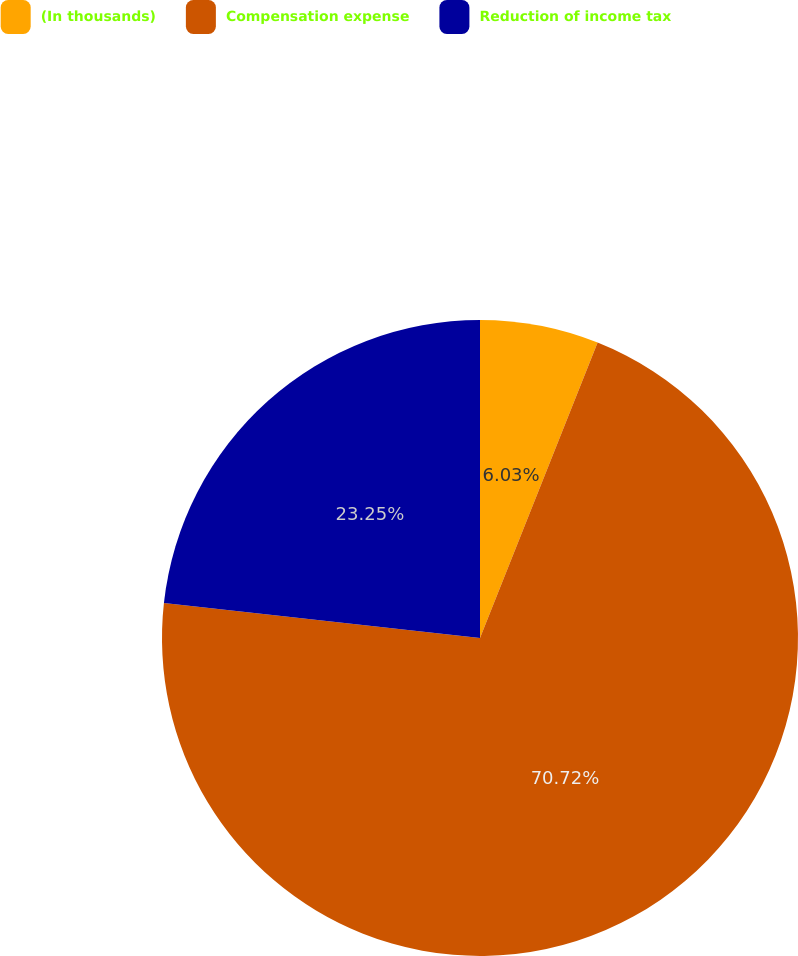Convert chart to OTSL. <chart><loc_0><loc_0><loc_500><loc_500><pie_chart><fcel>(In thousands)<fcel>Compensation expense<fcel>Reduction of income tax<nl><fcel>6.03%<fcel>70.73%<fcel>23.25%<nl></chart> 